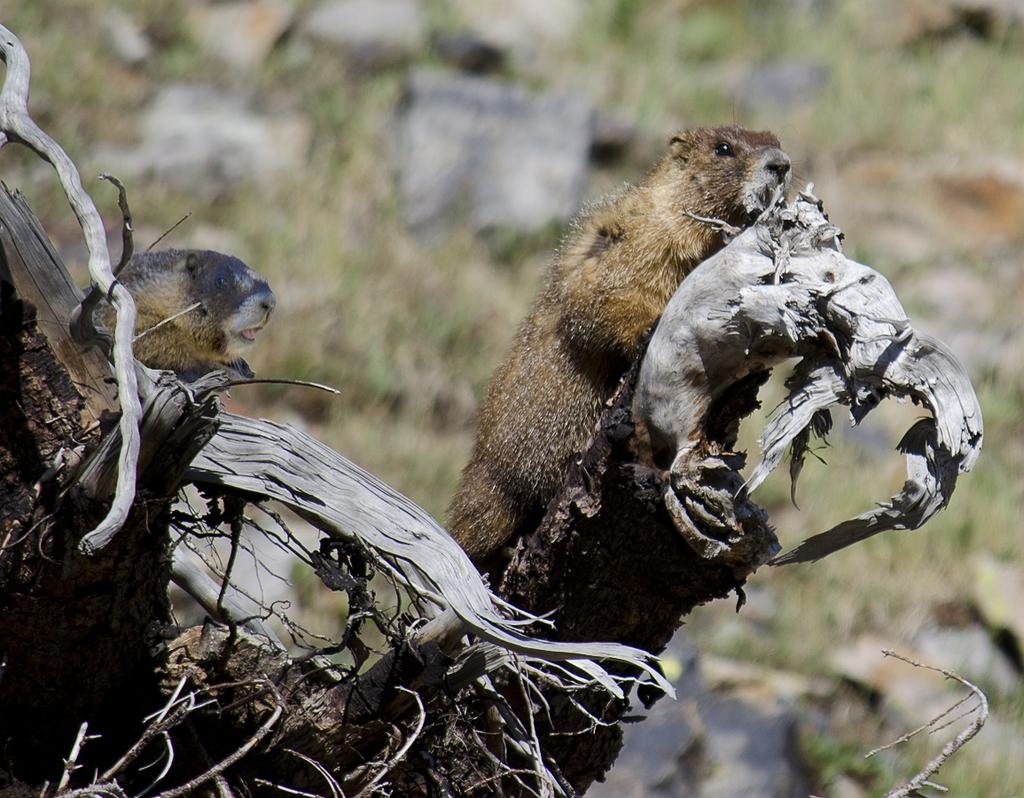What type of living organisms can be seen in the image? There are animals in the image. Where are the animals located? The animals are on a trunk. What colors are the animals in the image? The animals are in brown, cream, and black colors. Can you describe the background of the image? The background of the image is blurred. What type of sock is visible on the trunk in the image? There is no sock present in the image; it features animals on a trunk. What is the profit margin of the animals in the image? The image does not provide information about the profit margin of the animals, as it is not a commercial context. 